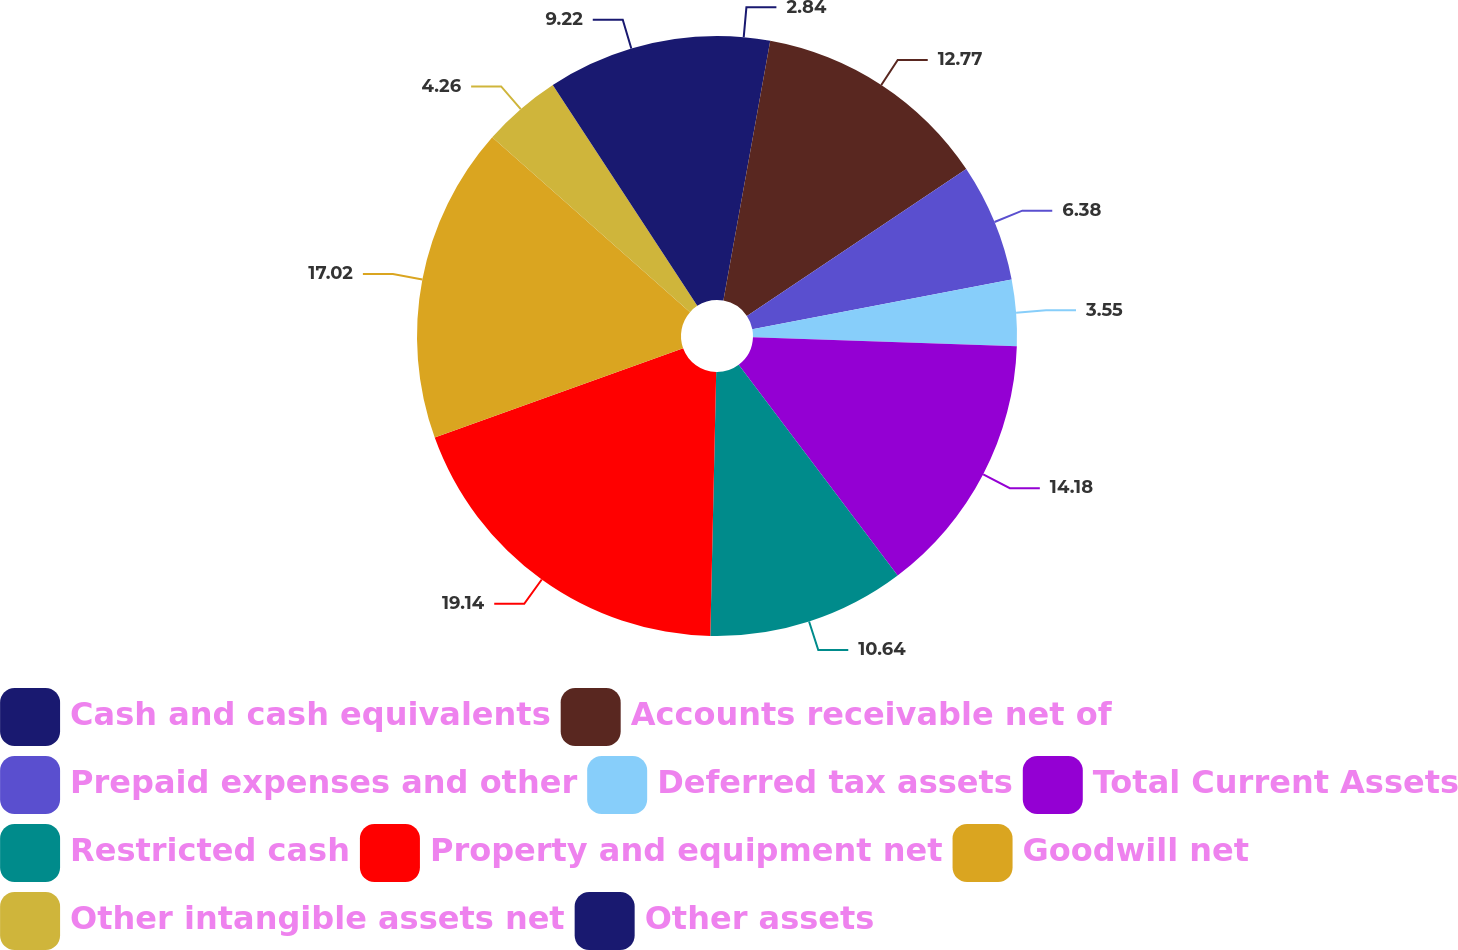<chart> <loc_0><loc_0><loc_500><loc_500><pie_chart><fcel>Cash and cash equivalents<fcel>Accounts receivable net of<fcel>Prepaid expenses and other<fcel>Deferred tax assets<fcel>Total Current Assets<fcel>Restricted cash<fcel>Property and equipment net<fcel>Goodwill net<fcel>Other intangible assets net<fcel>Other assets<nl><fcel>2.84%<fcel>12.77%<fcel>6.38%<fcel>3.55%<fcel>14.18%<fcel>10.64%<fcel>19.15%<fcel>17.02%<fcel>4.26%<fcel>9.22%<nl></chart> 